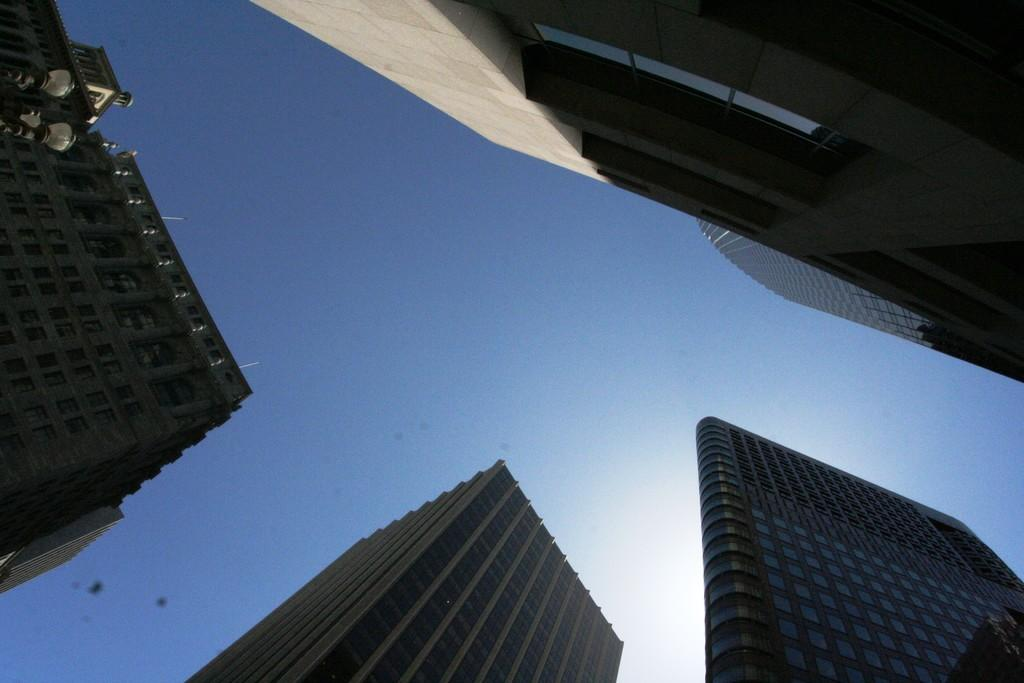What is the perspective of the image? The image depicts a place from the bottom. What type of structures can be seen in the image? There are buildings in the image. What feature do the buildings have? The buildings have glass windows. What type of lighting is visible in the image? There are lamps visible in the image. How many beds can be seen in the image? There are no beds present in the image. What historical event is depicted in the image? The image does not depict any historical event; it shows buildings with glass windows and lamps. 